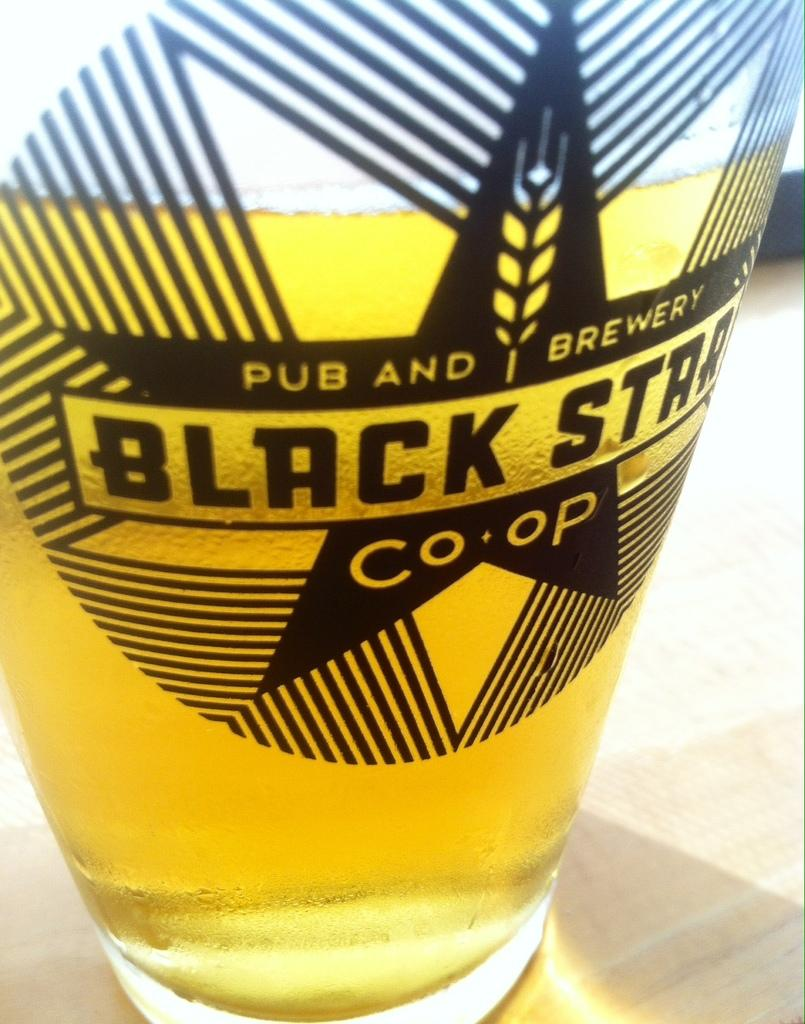Provide a one-sentence caption for the provided image. A glass of beer is decorated with the Black Star logo. 